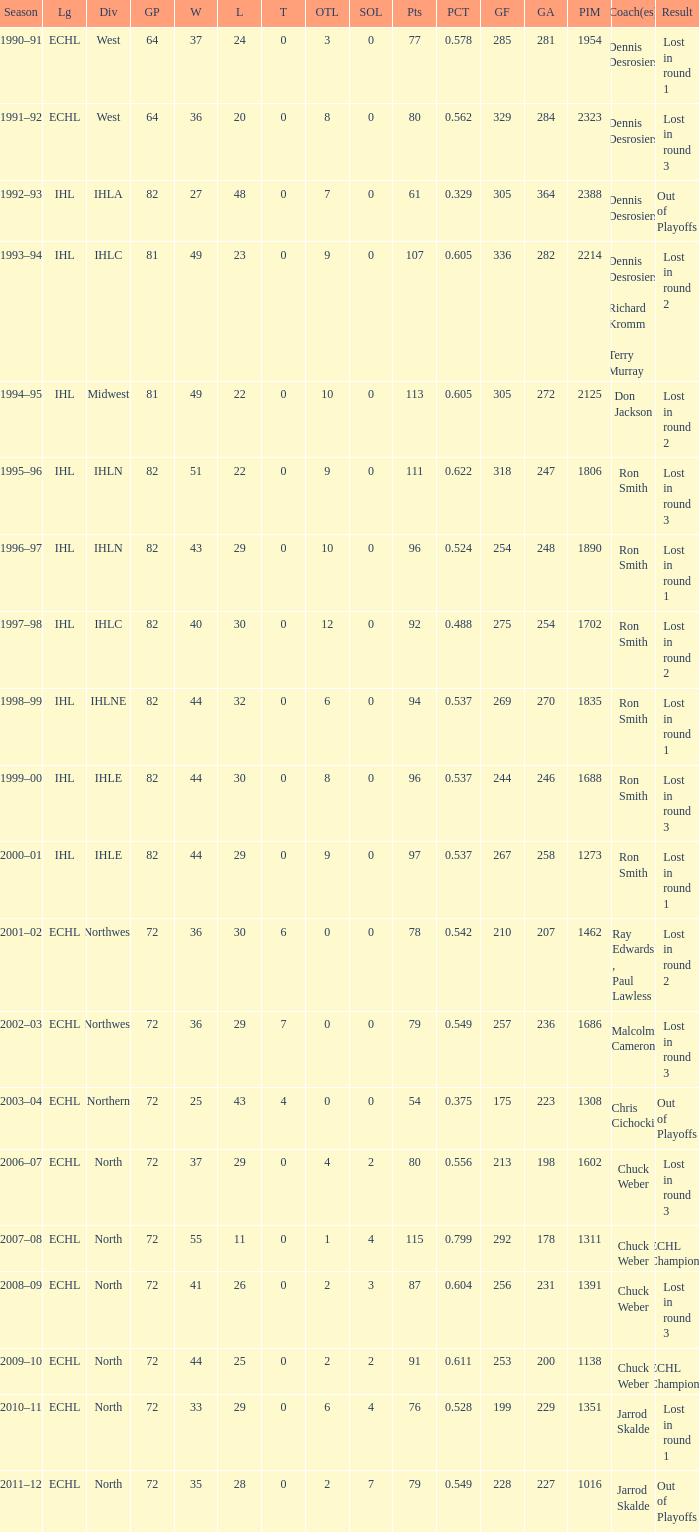What was the minimum L if the GA is 272? 22.0. 